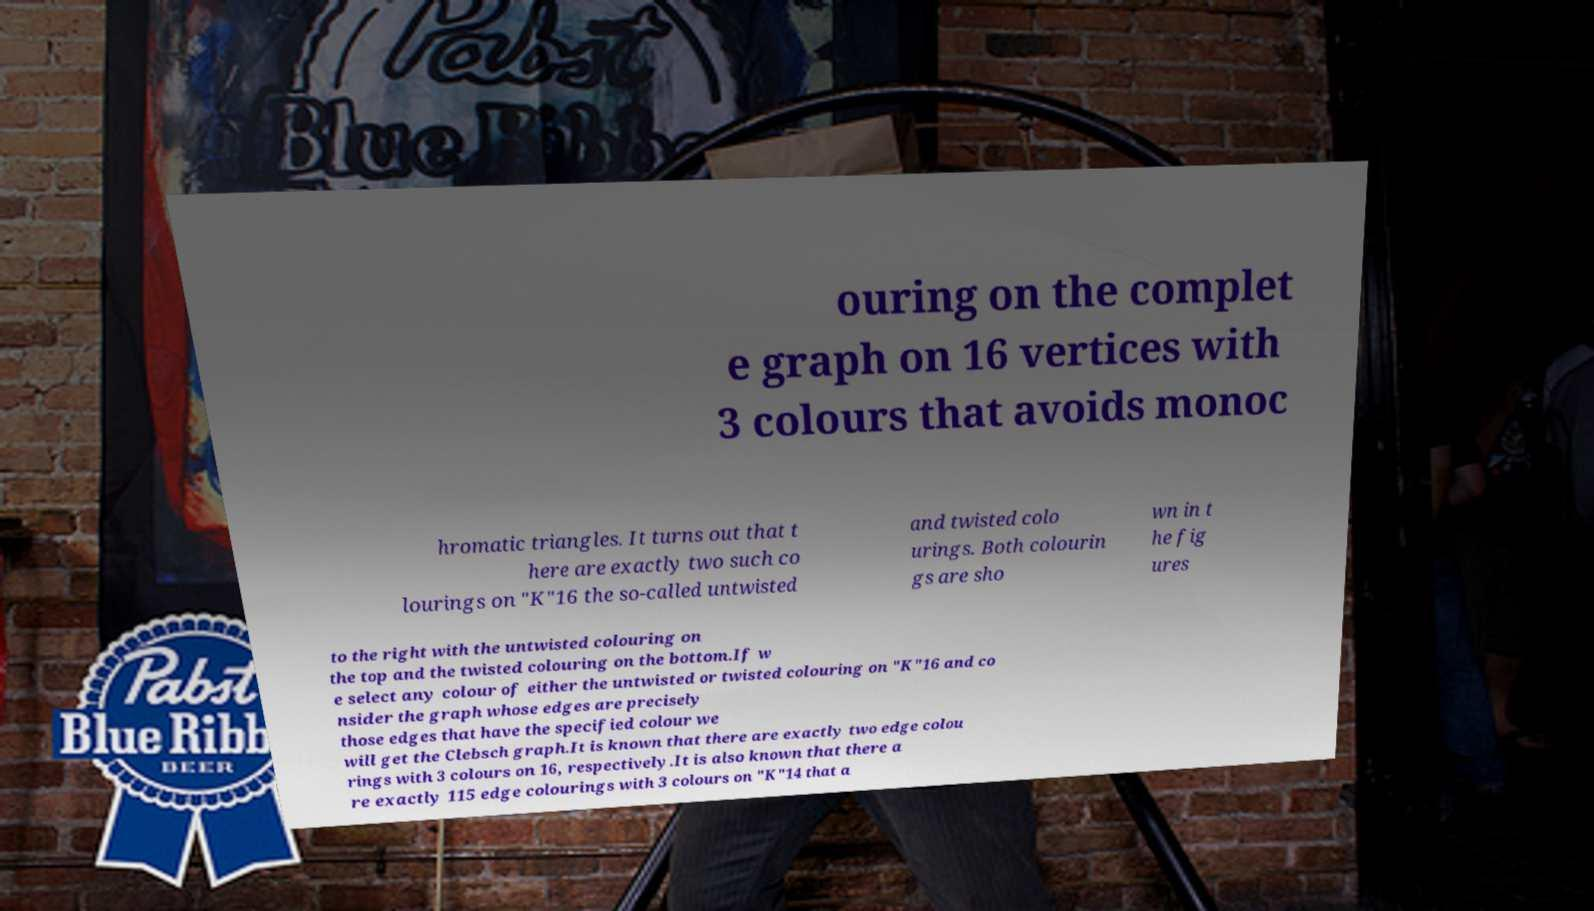I need the written content from this picture converted into text. Can you do that? ouring on the complet e graph on 16 vertices with 3 colours that avoids monoc hromatic triangles. It turns out that t here are exactly two such co lourings on "K"16 the so-called untwisted and twisted colo urings. Both colourin gs are sho wn in t he fig ures to the right with the untwisted colouring on the top and the twisted colouring on the bottom.If w e select any colour of either the untwisted or twisted colouring on "K"16 and co nsider the graph whose edges are precisely those edges that have the specified colour we will get the Clebsch graph.It is known that there are exactly two edge colou rings with 3 colours on 16, respectively.It is also known that there a re exactly 115 edge colourings with 3 colours on "K"14 that a 